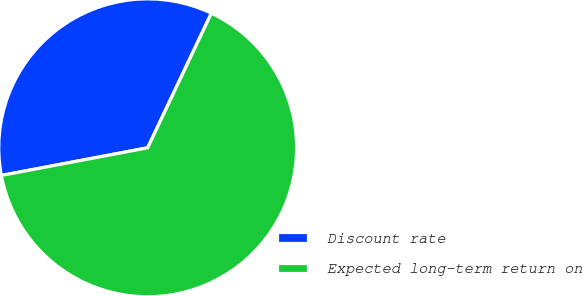Convert chart. <chart><loc_0><loc_0><loc_500><loc_500><pie_chart><fcel>Discount rate<fcel>Expected long-term return on<nl><fcel>35.01%<fcel>64.99%<nl></chart> 